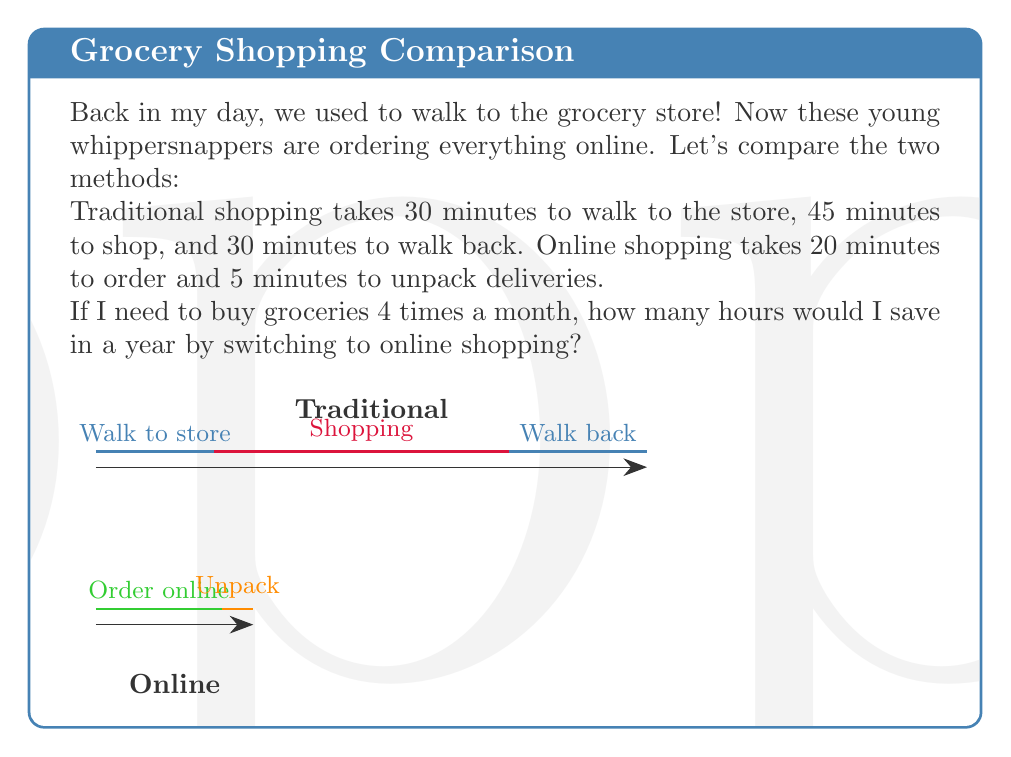What is the answer to this math problem? Let's break this down step-by-step:

1) First, let's calculate the time for traditional shopping:
   - Walking to store: 30 minutes
   - Shopping: 45 minutes
   - Walking back: 30 minutes
   Total time per trip: $30 + 45 + 30 = 105$ minutes

2) Now, let's calculate the time for online shopping:
   - Ordering online: 20 minutes
   - Unpacking deliveries: 5 minutes
   Total time per order: $20 + 5 = 25$ minutes

3) Time saved per grocery trip:
   $105 - 25 = 80$ minutes

4) Now, let's calculate for a year:
   - Trips per month: 4
   - Months in a year: 12
   Total trips per year: $4 * 12 = 48$

5) Time saved in a year:
   $80 * 48 = 3840$ minutes

6) Convert minutes to hours:
   $3840 \div 60 = 64$ hours

Therefore, by switching to online shopping, I would save 64 hours in a year.
Answer: 64 hours 